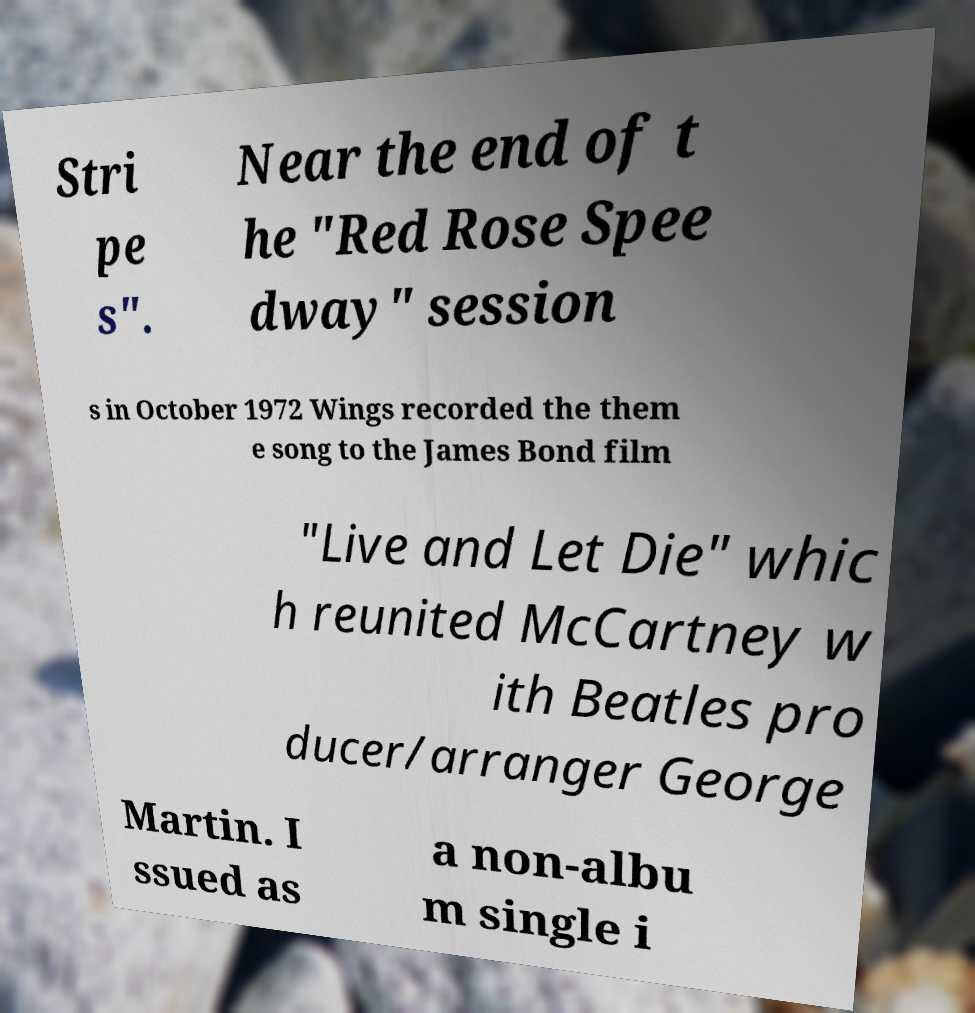For documentation purposes, I need the text within this image transcribed. Could you provide that? Stri pe s". Near the end of t he "Red Rose Spee dway" session s in October 1972 Wings recorded the them e song to the James Bond film "Live and Let Die" whic h reunited McCartney w ith Beatles pro ducer/arranger George Martin. I ssued as a non-albu m single i 